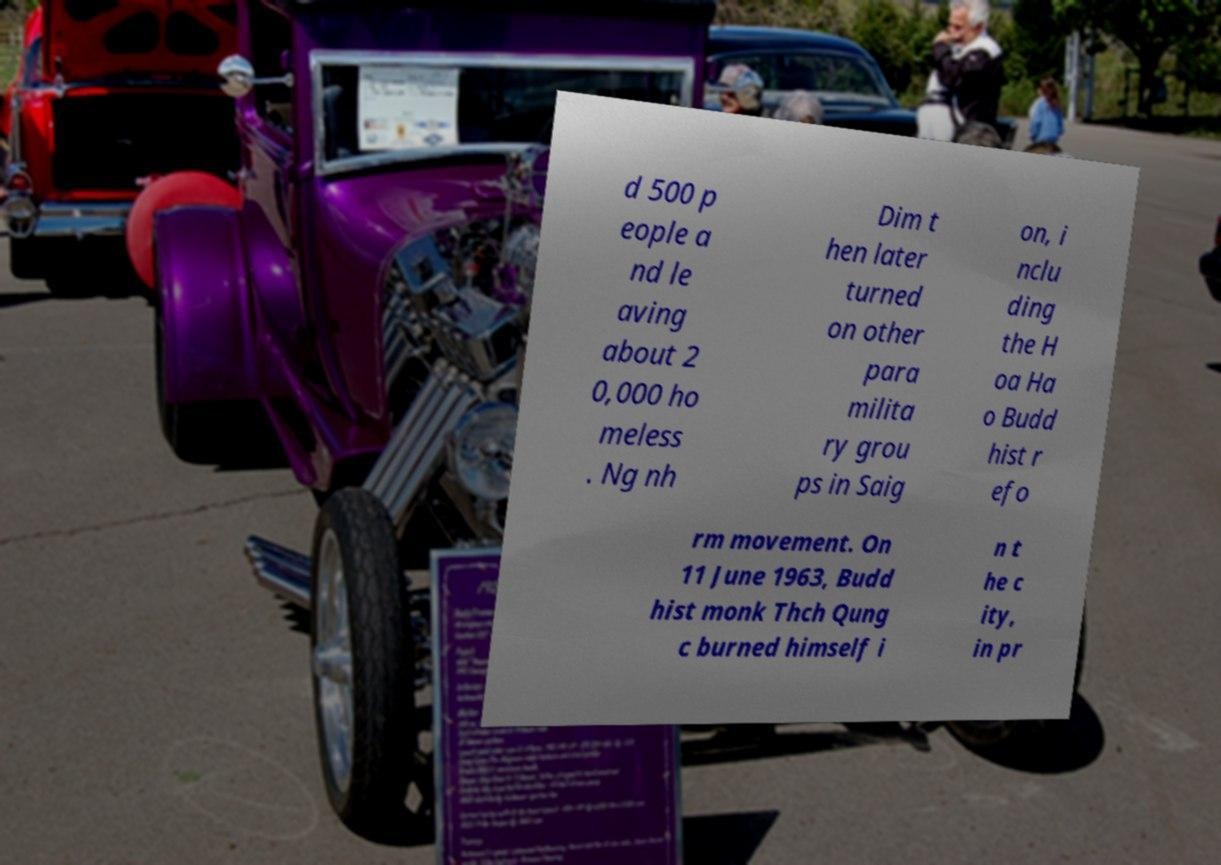Could you extract and type out the text from this image? d 500 p eople a nd le aving about 2 0,000 ho meless . Ng nh Dim t hen later turned on other para milita ry grou ps in Saig on, i nclu ding the H oa Ha o Budd hist r efo rm movement. On 11 June 1963, Budd hist monk Thch Qung c burned himself i n t he c ity, in pr 